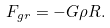Convert formula to latex. <formula><loc_0><loc_0><loc_500><loc_500>F _ { g r } = - G \rho R .</formula> 